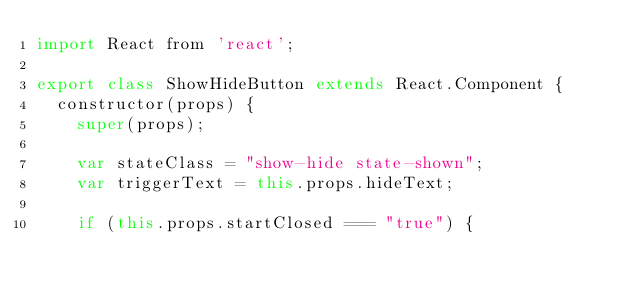<code> <loc_0><loc_0><loc_500><loc_500><_JavaScript_>import React from 'react';

export class ShowHideButton extends React.Component {
  constructor(props) {
    super(props);

    var stateClass = "show-hide state-shown";
    var triggerText = this.props.hideText;

    if (this.props.startClosed === "true") {</code> 